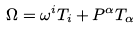Convert formula to latex. <formula><loc_0><loc_0><loc_500><loc_500>\Omega = \omega ^ { i } T _ { i } + P ^ { \alpha } T _ { \alpha }</formula> 